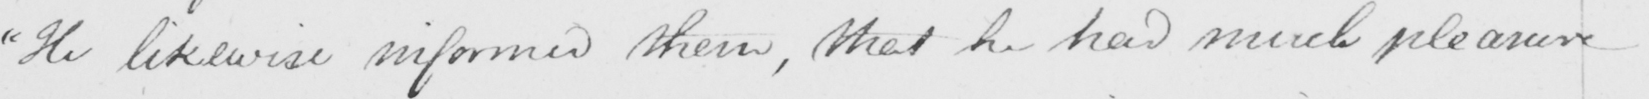Can you tell me what this handwritten text says? " He likewise informed them , that he had much pleasure 